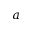Convert formula to latex. <formula><loc_0><loc_0><loc_500><loc_500>a</formula> 